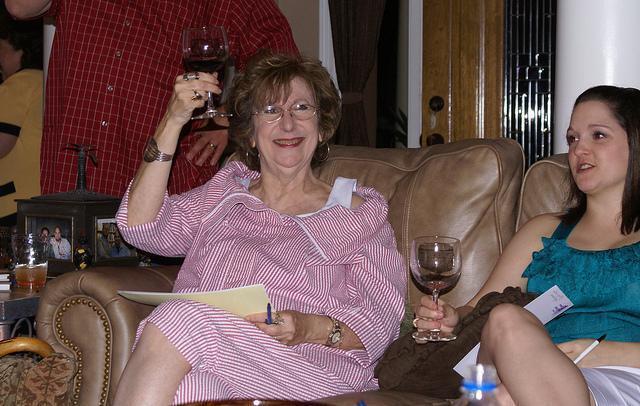How many couches are visible?
Give a very brief answer. 1. How many people can be seen?
Give a very brief answer. 4. How many wine glasses can be seen?
Give a very brief answer. 2. 